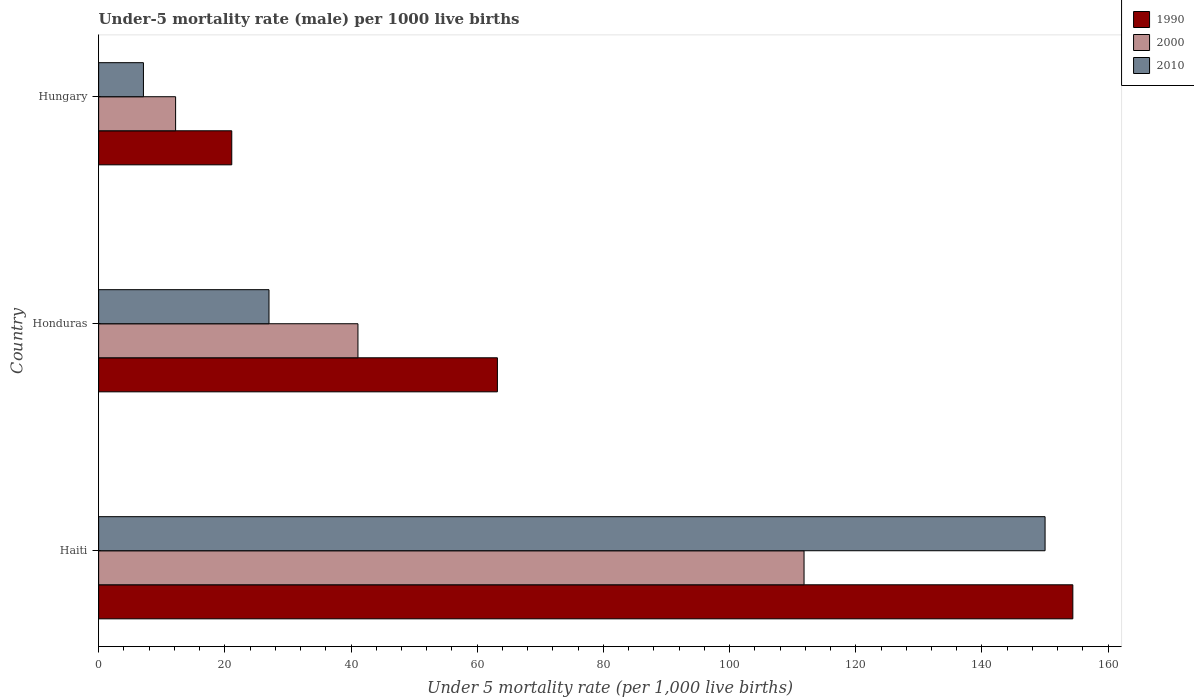How many groups of bars are there?
Provide a short and direct response. 3. How many bars are there on the 2nd tick from the top?
Give a very brief answer. 3. How many bars are there on the 1st tick from the bottom?
Offer a very short reply. 3. What is the label of the 2nd group of bars from the top?
Give a very brief answer. Honduras. Across all countries, what is the maximum under-five mortality rate in 2010?
Provide a short and direct response. 150. Across all countries, what is the minimum under-five mortality rate in 2000?
Offer a terse response. 12.2. In which country was the under-five mortality rate in 2010 maximum?
Provide a succinct answer. Haiti. In which country was the under-five mortality rate in 1990 minimum?
Provide a short and direct response. Hungary. What is the total under-five mortality rate in 2000 in the graph?
Offer a very short reply. 165.1. What is the difference between the under-five mortality rate in 1990 in Haiti and that in Hungary?
Offer a terse response. 133.3. What is the difference between the under-five mortality rate in 2000 in Honduras and the under-five mortality rate in 2010 in Hungary?
Keep it short and to the point. 34. What is the average under-five mortality rate in 2010 per country?
Offer a terse response. 61.37. What is the difference between the under-five mortality rate in 2000 and under-five mortality rate in 2010 in Haiti?
Provide a succinct answer. -38.2. In how many countries, is the under-five mortality rate in 1990 greater than 16 ?
Offer a terse response. 3. What is the ratio of the under-five mortality rate in 2000 in Honduras to that in Hungary?
Keep it short and to the point. 3.37. Is the under-five mortality rate in 1990 in Haiti less than that in Honduras?
Your answer should be compact. No. What is the difference between the highest and the second highest under-five mortality rate in 1990?
Provide a short and direct response. 91.2. What is the difference between the highest and the lowest under-five mortality rate in 2010?
Offer a terse response. 142.9. What does the 2nd bar from the bottom in Hungary represents?
Offer a terse response. 2000. How many bars are there?
Provide a short and direct response. 9. Are all the bars in the graph horizontal?
Offer a very short reply. Yes. How many countries are there in the graph?
Ensure brevity in your answer.  3. What is the difference between two consecutive major ticks on the X-axis?
Your response must be concise. 20. Does the graph contain grids?
Offer a very short reply. No. How are the legend labels stacked?
Your response must be concise. Vertical. What is the title of the graph?
Ensure brevity in your answer.  Under-5 mortality rate (male) per 1000 live births. Does "1985" appear as one of the legend labels in the graph?
Your response must be concise. No. What is the label or title of the X-axis?
Make the answer very short. Under 5 mortality rate (per 1,0 live births). What is the label or title of the Y-axis?
Ensure brevity in your answer.  Country. What is the Under 5 mortality rate (per 1,000 live births) in 1990 in Haiti?
Your answer should be very brief. 154.4. What is the Under 5 mortality rate (per 1,000 live births) of 2000 in Haiti?
Make the answer very short. 111.8. What is the Under 5 mortality rate (per 1,000 live births) in 2010 in Haiti?
Ensure brevity in your answer.  150. What is the Under 5 mortality rate (per 1,000 live births) of 1990 in Honduras?
Offer a terse response. 63.2. What is the Under 5 mortality rate (per 1,000 live births) of 2000 in Honduras?
Ensure brevity in your answer.  41.1. What is the Under 5 mortality rate (per 1,000 live births) of 1990 in Hungary?
Make the answer very short. 21.1. Across all countries, what is the maximum Under 5 mortality rate (per 1,000 live births) in 1990?
Provide a succinct answer. 154.4. Across all countries, what is the maximum Under 5 mortality rate (per 1,000 live births) in 2000?
Give a very brief answer. 111.8. Across all countries, what is the maximum Under 5 mortality rate (per 1,000 live births) in 2010?
Your answer should be very brief. 150. Across all countries, what is the minimum Under 5 mortality rate (per 1,000 live births) of 1990?
Offer a very short reply. 21.1. What is the total Under 5 mortality rate (per 1,000 live births) of 1990 in the graph?
Your response must be concise. 238.7. What is the total Under 5 mortality rate (per 1,000 live births) in 2000 in the graph?
Make the answer very short. 165.1. What is the total Under 5 mortality rate (per 1,000 live births) in 2010 in the graph?
Make the answer very short. 184.1. What is the difference between the Under 5 mortality rate (per 1,000 live births) of 1990 in Haiti and that in Honduras?
Provide a succinct answer. 91.2. What is the difference between the Under 5 mortality rate (per 1,000 live births) of 2000 in Haiti and that in Honduras?
Keep it short and to the point. 70.7. What is the difference between the Under 5 mortality rate (per 1,000 live births) in 2010 in Haiti and that in Honduras?
Your response must be concise. 123. What is the difference between the Under 5 mortality rate (per 1,000 live births) of 1990 in Haiti and that in Hungary?
Your response must be concise. 133.3. What is the difference between the Under 5 mortality rate (per 1,000 live births) in 2000 in Haiti and that in Hungary?
Provide a succinct answer. 99.6. What is the difference between the Under 5 mortality rate (per 1,000 live births) of 2010 in Haiti and that in Hungary?
Keep it short and to the point. 142.9. What is the difference between the Under 5 mortality rate (per 1,000 live births) of 1990 in Honduras and that in Hungary?
Keep it short and to the point. 42.1. What is the difference between the Under 5 mortality rate (per 1,000 live births) of 2000 in Honduras and that in Hungary?
Offer a terse response. 28.9. What is the difference between the Under 5 mortality rate (per 1,000 live births) of 1990 in Haiti and the Under 5 mortality rate (per 1,000 live births) of 2000 in Honduras?
Provide a succinct answer. 113.3. What is the difference between the Under 5 mortality rate (per 1,000 live births) of 1990 in Haiti and the Under 5 mortality rate (per 1,000 live births) of 2010 in Honduras?
Keep it short and to the point. 127.4. What is the difference between the Under 5 mortality rate (per 1,000 live births) of 2000 in Haiti and the Under 5 mortality rate (per 1,000 live births) of 2010 in Honduras?
Provide a short and direct response. 84.8. What is the difference between the Under 5 mortality rate (per 1,000 live births) in 1990 in Haiti and the Under 5 mortality rate (per 1,000 live births) in 2000 in Hungary?
Offer a terse response. 142.2. What is the difference between the Under 5 mortality rate (per 1,000 live births) of 1990 in Haiti and the Under 5 mortality rate (per 1,000 live births) of 2010 in Hungary?
Make the answer very short. 147.3. What is the difference between the Under 5 mortality rate (per 1,000 live births) of 2000 in Haiti and the Under 5 mortality rate (per 1,000 live births) of 2010 in Hungary?
Keep it short and to the point. 104.7. What is the difference between the Under 5 mortality rate (per 1,000 live births) of 1990 in Honduras and the Under 5 mortality rate (per 1,000 live births) of 2010 in Hungary?
Give a very brief answer. 56.1. What is the difference between the Under 5 mortality rate (per 1,000 live births) of 2000 in Honduras and the Under 5 mortality rate (per 1,000 live births) of 2010 in Hungary?
Your response must be concise. 34. What is the average Under 5 mortality rate (per 1,000 live births) in 1990 per country?
Provide a short and direct response. 79.57. What is the average Under 5 mortality rate (per 1,000 live births) of 2000 per country?
Provide a succinct answer. 55.03. What is the average Under 5 mortality rate (per 1,000 live births) in 2010 per country?
Keep it short and to the point. 61.37. What is the difference between the Under 5 mortality rate (per 1,000 live births) of 1990 and Under 5 mortality rate (per 1,000 live births) of 2000 in Haiti?
Your answer should be compact. 42.6. What is the difference between the Under 5 mortality rate (per 1,000 live births) in 1990 and Under 5 mortality rate (per 1,000 live births) in 2010 in Haiti?
Ensure brevity in your answer.  4.4. What is the difference between the Under 5 mortality rate (per 1,000 live births) of 2000 and Under 5 mortality rate (per 1,000 live births) of 2010 in Haiti?
Give a very brief answer. -38.2. What is the difference between the Under 5 mortality rate (per 1,000 live births) of 1990 and Under 5 mortality rate (per 1,000 live births) of 2000 in Honduras?
Your answer should be compact. 22.1. What is the difference between the Under 5 mortality rate (per 1,000 live births) in 1990 and Under 5 mortality rate (per 1,000 live births) in 2010 in Honduras?
Offer a very short reply. 36.2. What is the difference between the Under 5 mortality rate (per 1,000 live births) in 2000 and Under 5 mortality rate (per 1,000 live births) in 2010 in Honduras?
Make the answer very short. 14.1. What is the difference between the Under 5 mortality rate (per 1,000 live births) in 1990 and Under 5 mortality rate (per 1,000 live births) in 2000 in Hungary?
Give a very brief answer. 8.9. What is the difference between the Under 5 mortality rate (per 1,000 live births) in 1990 and Under 5 mortality rate (per 1,000 live births) in 2010 in Hungary?
Keep it short and to the point. 14. What is the difference between the Under 5 mortality rate (per 1,000 live births) of 2000 and Under 5 mortality rate (per 1,000 live births) of 2010 in Hungary?
Provide a succinct answer. 5.1. What is the ratio of the Under 5 mortality rate (per 1,000 live births) in 1990 in Haiti to that in Honduras?
Make the answer very short. 2.44. What is the ratio of the Under 5 mortality rate (per 1,000 live births) of 2000 in Haiti to that in Honduras?
Provide a succinct answer. 2.72. What is the ratio of the Under 5 mortality rate (per 1,000 live births) in 2010 in Haiti to that in Honduras?
Make the answer very short. 5.56. What is the ratio of the Under 5 mortality rate (per 1,000 live births) in 1990 in Haiti to that in Hungary?
Offer a terse response. 7.32. What is the ratio of the Under 5 mortality rate (per 1,000 live births) of 2000 in Haiti to that in Hungary?
Provide a succinct answer. 9.16. What is the ratio of the Under 5 mortality rate (per 1,000 live births) in 2010 in Haiti to that in Hungary?
Make the answer very short. 21.13. What is the ratio of the Under 5 mortality rate (per 1,000 live births) in 1990 in Honduras to that in Hungary?
Ensure brevity in your answer.  3. What is the ratio of the Under 5 mortality rate (per 1,000 live births) of 2000 in Honduras to that in Hungary?
Offer a very short reply. 3.37. What is the ratio of the Under 5 mortality rate (per 1,000 live births) in 2010 in Honduras to that in Hungary?
Provide a short and direct response. 3.8. What is the difference between the highest and the second highest Under 5 mortality rate (per 1,000 live births) of 1990?
Provide a succinct answer. 91.2. What is the difference between the highest and the second highest Under 5 mortality rate (per 1,000 live births) in 2000?
Give a very brief answer. 70.7. What is the difference between the highest and the second highest Under 5 mortality rate (per 1,000 live births) of 2010?
Offer a very short reply. 123. What is the difference between the highest and the lowest Under 5 mortality rate (per 1,000 live births) in 1990?
Provide a succinct answer. 133.3. What is the difference between the highest and the lowest Under 5 mortality rate (per 1,000 live births) in 2000?
Your response must be concise. 99.6. What is the difference between the highest and the lowest Under 5 mortality rate (per 1,000 live births) in 2010?
Your response must be concise. 142.9. 